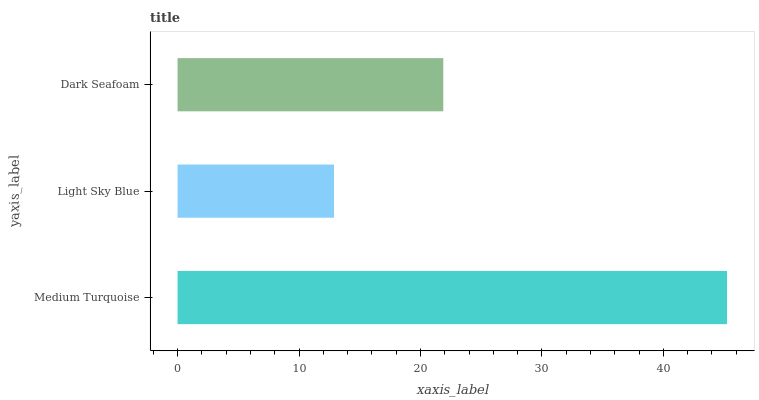Is Light Sky Blue the minimum?
Answer yes or no. Yes. Is Medium Turquoise the maximum?
Answer yes or no. Yes. Is Dark Seafoam the minimum?
Answer yes or no. No. Is Dark Seafoam the maximum?
Answer yes or no. No. Is Dark Seafoam greater than Light Sky Blue?
Answer yes or no. Yes. Is Light Sky Blue less than Dark Seafoam?
Answer yes or no. Yes. Is Light Sky Blue greater than Dark Seafoam?
Answer yes or no. No. Is Dark Seafoam less than Light Sky Blue?
Answer yes or no. No. Is Dark Seafoam the high median?
Answer yes or no. Yes. Is Dark Seafoam the low median?
Answer yes or no. Yes. Is Medium Turquoise the high median?
Answer yes or no. No. Is Light Sky Blue the low median?
Answer yes or no. No. 